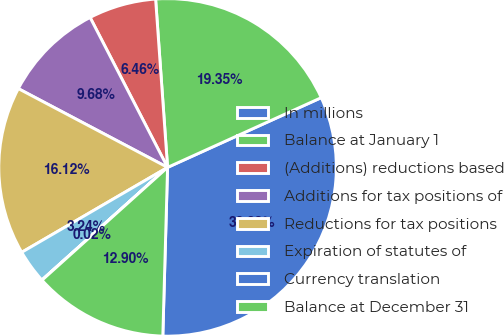Convert chart. <chart><loc_0><loc_0><loc_500><loc_500><pie_chart><fcel>In millions<fcel>Balance at January 1<fcel>(Additions) reductions based<fcel>Additions for tax positions of<fcel>Reductions for tax positions<fcel>Expiration of statutes of<fcel>Currency translation<fcel>Balance at December 31<nl><fcel>32.23%<fcel>19.35%<fcel>6.46%<fcel>9.68%<fcel>16.12%<fcel>3.24%<fcel>0.02%<fcel>12.9%<nl></chart> 